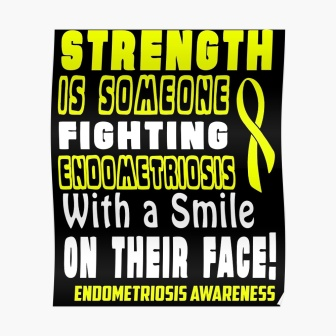How does the poster visually convey its message? The poster uses bold yellow text against a black background to ensure the message stands out and catches the viewer’s attention. The large text size for key words like 'STRENGTH' emphasizes the theme of resilience. Additionally, the yellow ribbon on the right side serves as a visual symbol for awareness, making it instantly recognizable. 